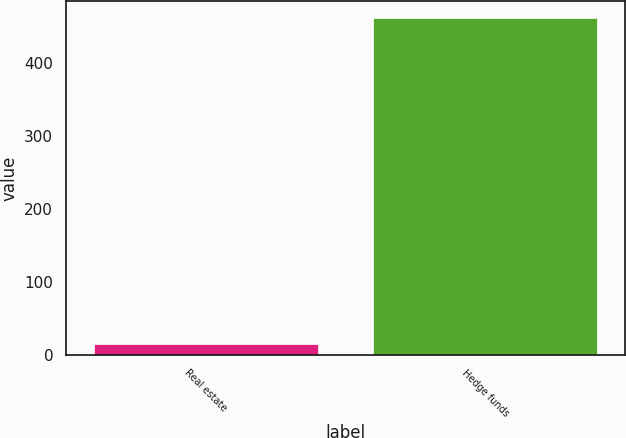Convert chart. <chart><loc_0><loc_0><loc_500><loc_500><bar_chart><fcel>Real estate<fcel>Hedge funds<nl><fcel>14<fcel>462<nl></chart> 